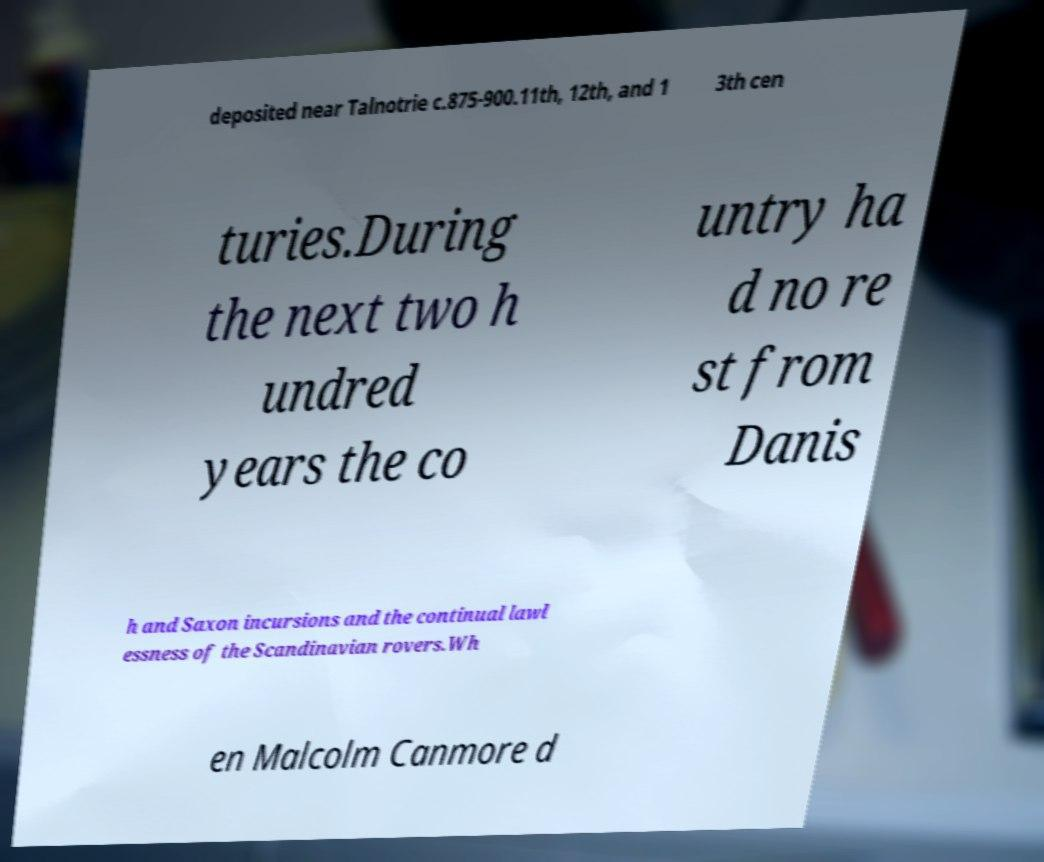There's text embedded in this image that I need extracted. Can you transcribe it verbatim? deposited near Talnotrie c.875-900.11th, 12th, and 1 3th cen turies.During the next two h undred years the co untry ha d no re st from Danis h and Saxon incursions and the continual lawl essness of the Scandinavian rovers.Wh en Malcolm Canmore d 